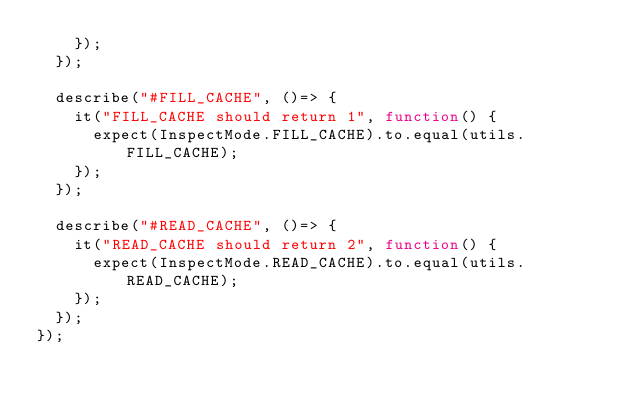Convert code to text. <code><loc_0><loc_0><loc_500><loc_500><_TypeScript_>    });
  });

  describe("#FILL_CACHE", ()=> {
    it("FILL_CACHE should return 1", function() {
      expect(InspectMode.FILL_CACHE).to.equal(utils.FILL_CACHE);
    });
  });

  describe("#READ_CACHE", ()=> {
    it("READ_CACHE should return 2", function() {
      expect(InspectMode.READ_CACHE).to.equal(utils.READ_CACHE);
    });
  });
});
</code> 